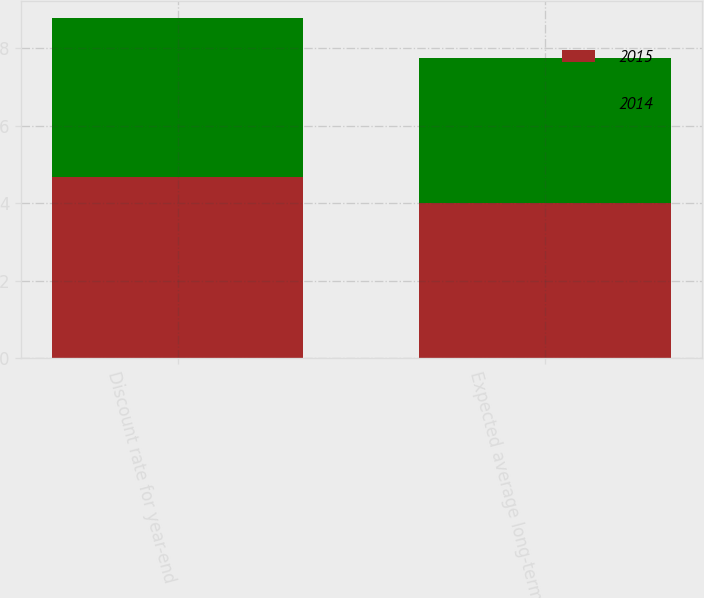<chart> <loc_0><loc_0><loc_500><loc_500><stacked_bar_chart><ecel><fcel>Discount rate for year-end<fcel>Expected average long-term<nl><fcel>2015<fcel>4.66<fcel>4<nl><fcel>2014<fcel>4.11<fcel>3.75<nl></chart> 